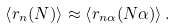<formula> <loc_0><loc_0><loc_500><loc_500>\left \langle r _ { n } ( N ) \right \rangle \approx \left \langle r _ { n \alpha } ( N \alpha ) \right \rangle .</formula> 